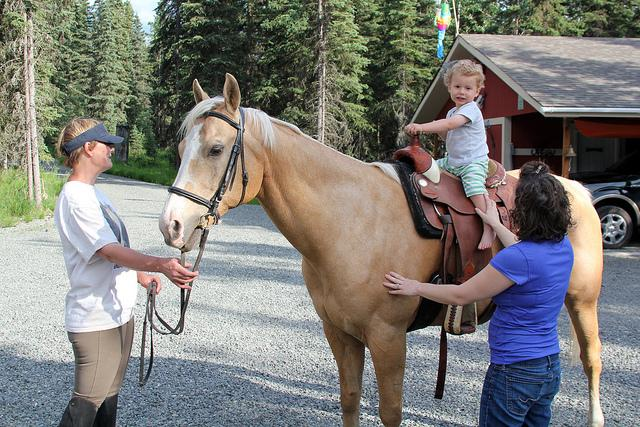Which one is probably the most proficient rider? Please explain your reasoning. tan pants. The one in tan pants is the oldest and is leading the horse. 